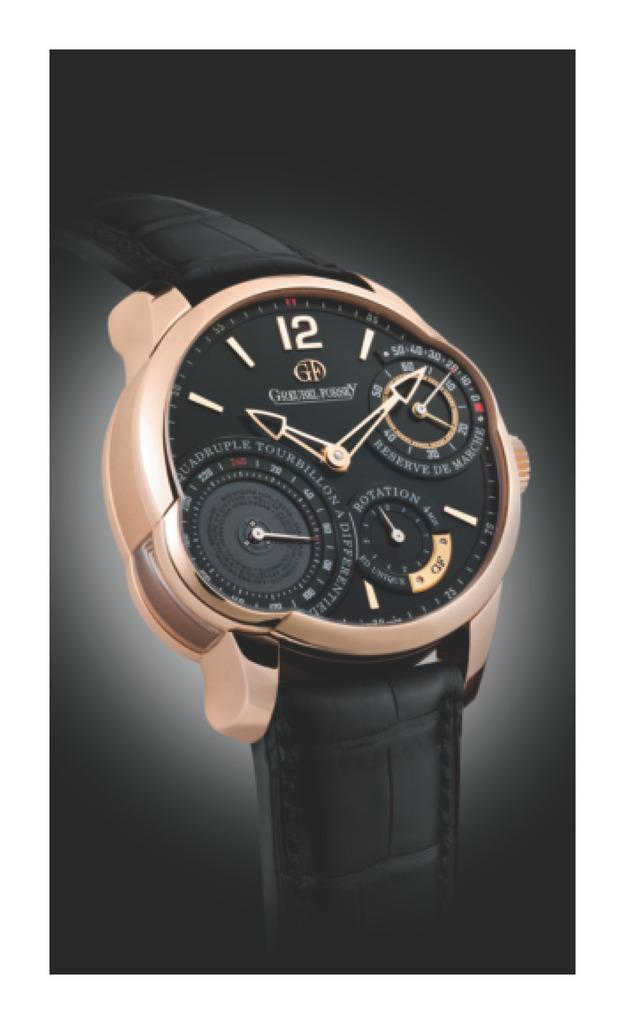<image>
Render a clear and concise summary of the photo. Black and goldwatch with the letters GF right under the number 12. 